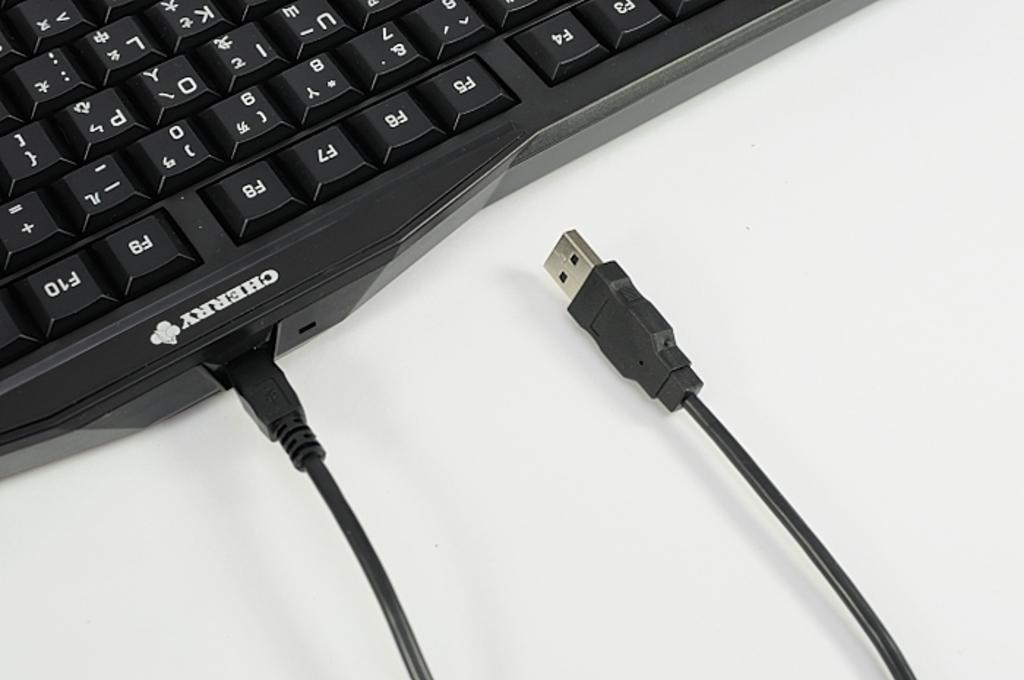Provide a one-sentence caption for the provided image. a cherry brand keyboard with a cable coming out of it. 